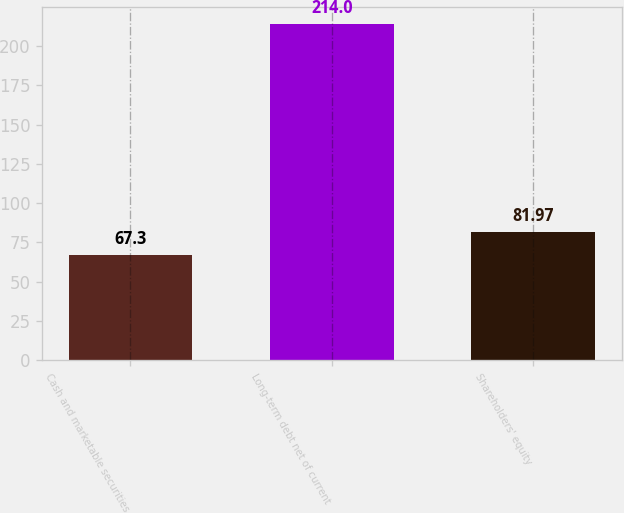Convert chart. <chart><loc_0><loc_0><loc_500><loc_500><bar_chart><fcel>Cash and marketable securities<fcel>Long-term debt net of current<fcel>Shareholders' equity<nl><fcel>67.3<fcel>214<fcel>81.97<nl></chart> 